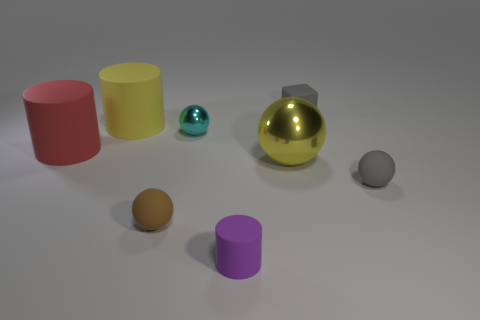What shape is the yellow object that is the same material as the cyan object?
Provide a short and direct response. Sphere. How many things are both on the left side of the yellow sphere and right of the big yellow rubber cylinder?
Keep it short and to the point. 3. Are there any tiny purple cylinders behind the yellow shiny ball?
Ensure brevity in your answer.  No. Do the small gray matte thing that is behind the large yellow rubber cylinder and the metal object that is behind the large red matte object have the same shape?
Make the answer very short. No. What number of objects are either spheres or things that are behind the yellow rubber cylinder?
Offer a very short reply. 5. How many other things are there of the same shape as the small brown matte object?
Keep it short and to the point. 3. Is the material of the big yellow object to the right of the cyan object the same as the brown sphere?
Make the answer very short. No. What number of objects are either tiny cyan balls or big green things?
Offer a terse response. 1. The red rubber thing that is the same shape as the yellow rubber thing is what size?
Keep it short and to the point. Large. What size is the yellow rubber cylinder?
Provide a succinct answer. Large. 